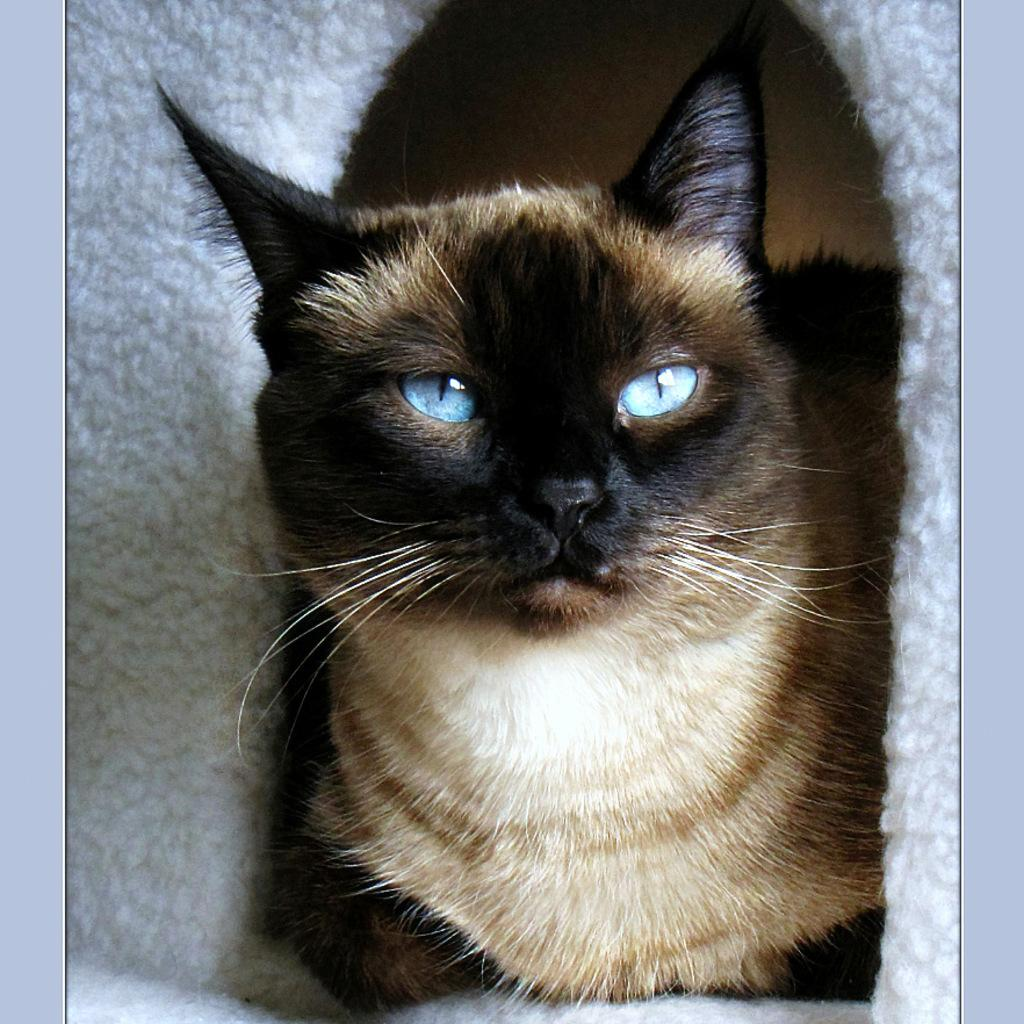What type of animal is in the image? There is a cat in the image. What is the cat sitting on? The cat is sitting on a white color cloth. How many dimes can be seen on the cat in the image? There are no dimes present on the cat in the image. What type of bait is the cat using to catch fish in the image? There is no bait or fishing activity depicted in the image; it simply features a cat sitting on a white color cloth. 